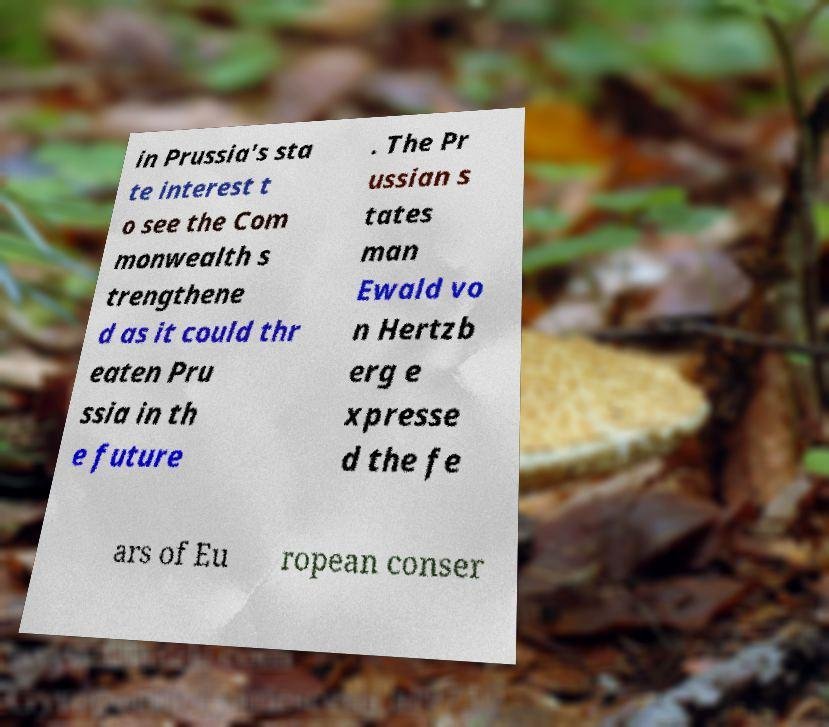What messages or text are displayed in this image? I need them in a readable, typed format. in Prussia's sta te interest t o see the Com monwealth s trengthene d as it could thr eaten Pru ssia in th e future . The Pr ussian s tates man Ewald vo n Hertzb erg e xpresse d the fe ars of Eu ropean conser 